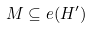<formula> <loc_0><loc_0><loc_500><loc_500>M \subseteq e ( H ^ { \prime } )</formula> 